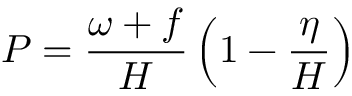Convert formula to latex. <formula><loc_0><loc_0><loc_500><loc_500>P = \frac { \omega + f } { H } \left ( 1 - \frac { \eta } { H } \right )</formula> 